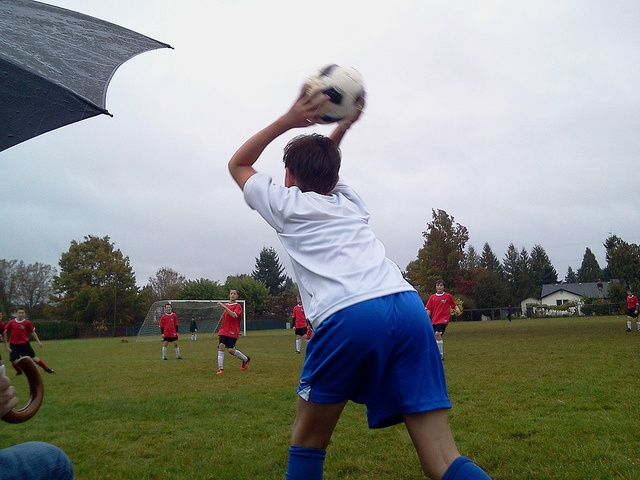Describe the objects in this image and their specific colors. I can see people in blue, black, lavender, navy, and gray tones, umbrella in lightgray, gray, and black tones, sports ball in blue, gray, lightgray, darkgray, and black tones, people in blue, black, maroon, gray, and darkgreen tones, and people in blue, black, maroon, brown, and gray tones in this image. 